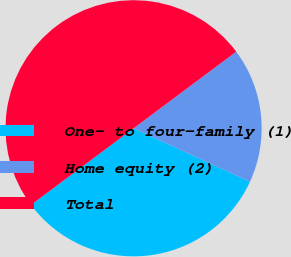Convert chart. <chart><loc_0><loc_0><loc_500><loc_500><pie_chart><fcel>One- to four-family (1)<fcel>Home equity (2)<fcel>Total<nl><fcel>32.94%<fcel>17.06%<fcel>50.0%<nl></chart> 